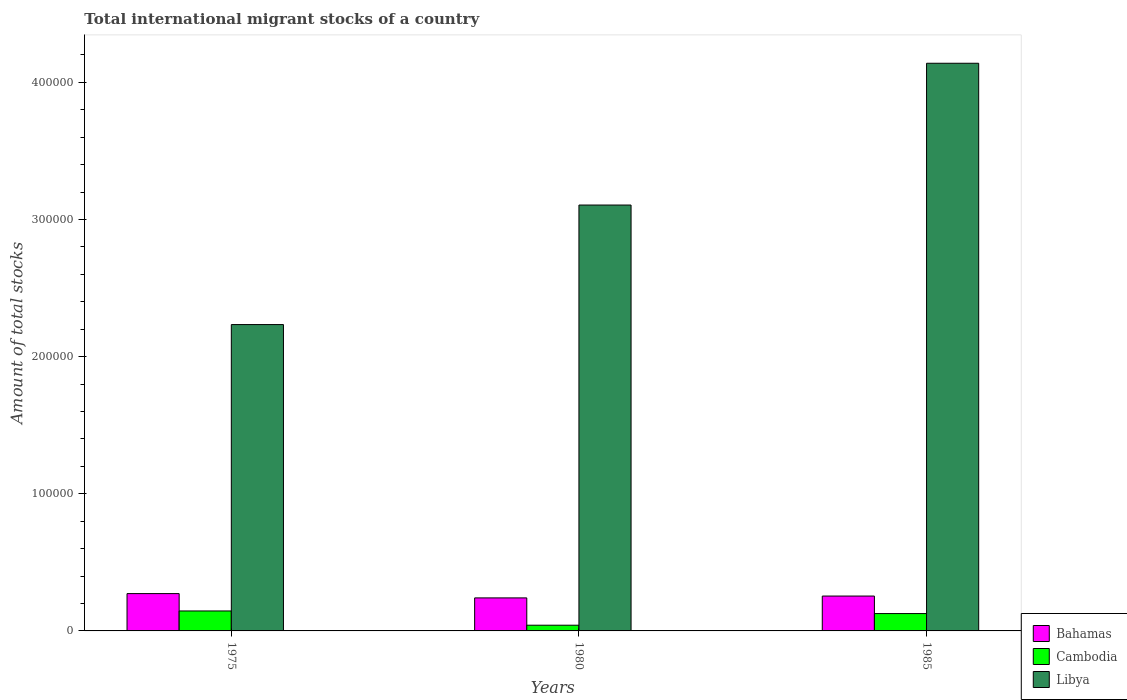How many different coloured bars are there?
Offer a very short reply. 3. How many groups of bars are there?
Your answer should be very brief. 3. Are the number of bars per tick equal to the number of legend labels?
Provide a succinct answer. Yes. How many bars are there on the 2nd tick from the left?
Your answer should be very brief. 3. What is the label of the 1st group of bars from the left?
Provide a succinct answer. 1975. In how many cases, is the number of bars for a given year not equal to the number of legend labels?
Offer a terse response. 0. What is the amount of total stocks in in Libya in 1975?
Provide a succinct answer. 2.23e+05. Across all years, what is the maximum amount of total stocks in in Libya?
Offer a very short reply. 4.14e+05. Across all years, what is the minimum amount of total stocks in in Libya?
Offer a terse response. 2.23e+05. In which year was the amount of total stocks in in Libya maximum?
Offer a terse response. 1985. In which year was the amount of total stocks in in Libya minimum?
Your answer should be very brief. 1975. What is the total amount of total stocks in in Libya in the graph?
Provide a succinct answer. 9.48e+05. What is the difference between the amount of total stocks in in Cambodia in 1975 and that in 1985?
Give a very brief answer. 1904. What is the difference between the amount of total stocks in in Bahamas in 1985 and the amount of total stocks in in Cambodia in 1980?
Provide a succinct answer. 2.13e+04. What is the average amount of total stocks in in Cambodia per year?
Give a very brief answer. 1.05e+04. In the year 1985, what is the difference between the amount of total stocks in in Bahamas and amount of total stocks in in Cambodia?
Give a very brief answer. 1.28e+04. What is the ratio of the amount of total stocks in in Cambodia in 1980 to that in 1985?
Ensure brevity in your answer.  0.33. What is the difference between the highest and the second highest amount of total stocks in in Libya?
Keep it short and to the point. 1.03e+05. What is the difference between the highest and the lowest amount of total stocks in in Bahamas?
Offer a very short reply. 3139. What does the 3rd bar from the left in 1980 represents?
Offer a very short reply. Libya. What does the 2nd bar from the right in 1975 represents?
Your response must be concise. Cambodia. Is it the case that in every year, the sum of the amount of total stocks in in Cambodia and amount of total stocks in in Bahamas is greater than the amount of total stocks in in Libya?
Your answer should be compact. No. Are all the bars in the graph horizontal?
Make the answer very short. No. What is the difference between two consecutive major ticks on the Y-axis?
Your answer should be very brief. 1.00e+05. Where does the legend appear in the graph?
Your answer should be very brief. Bottom right. What is the title of the graph?
Make the answer very short. Total international migrant stocks of a country. What is the label or title of the X-axis?
Provide a short and direct response. Years. What is the label or title of the Y-axis?
Offer a terse response. Amount of total stocks. What is the Amount of total stocks in Bahamas in 1975?
Your answer should be compact. 2.72e+04. What is the Amount of total stocks in Cambodia in 1975?
Your answer should be very brief. 1.46e+04. What is the Amount of total stocks in Libya in 1975?
Ensure brevity in your answer.  2.23e+05. What is the Amount of total stocks in Bahamas in 1980?
Offer a terse response. 2.41e+04. What is the Amount of total stocks of Cambodia in 1980?
Offer a very short reply. 4168. What is the Amount of total stocks in Libya in 1980?
Your response must be concise. 3.11e+05. What is the Amount of total stocks of Bahamas in 1985?
Your answer should be compact. 2.54e+04. What is the Amount of total stocks of Cambodia in 1985?
Offer a terse response. 1.26e+04. What is the Amount of total stocks of Libya in 1985?
Make the answer very short. 4.14e+05. Across all years, what is the maximum Amount of total stocks in Bahamas?
Provide a succinct answer. 2.72e+04. Across all years, what is the maximum Amount of total stocks in Cambodia?
Offer a terse response. 1.46e+04. Across all years, what is the maximum Amount of total stocks in Libya?
Provide a short and direct response. 4.14e+05. Across all years, what is the minimum Amount of total stocks of Bahamas?
Keep it short and to the point. 2.41e+04. Across all years, what is the minimum Amount of total stocks of Cambodia?
Provide a succinct answer. 4168. Across all years, what is the minimum Amount of total stocks in Libya?
Your answer should be compact. 2.23e+05. What is the total Amount of total stocks of Bahamas in the graph?
Offer a terse response. 7.67e+04. What is the total Amount of total stocks of Cambodia in the graph?
Give a very brief answer. 3.14e+04. What is the total Amount of total stocks in Libya in the graph?
Provide a short and direct response. 9.48e+05. What is the difference between the Amount of total stocks of Bahamas in 1975 and that in 1980?
Your response must be concise. 3139. What is the difference between the Amount of total stocks of Cambodia in 1975 and that in 1980?
Provide a succinct answer. 1.04e+04. What is the difference between the Amount of total stocks of Libya in 1975 and that in 1980?
Provide a short and direct response. -8.72e+04. What is the difference between the Amount of total stocks in Bahamas in 1975 and that in 1985?
Your response must be concise. 1788. What is the difference between the Amount of total stocks of Cambodia in 1975 and that in 1985?
Keep it short and to the point. 1904. What is the difference between the Amount of total stocks in Libya in 1975 and that in 1985?
Ensure brevity in your answer.  -1.91e+05. What is the difference between the Amount of total stocks in Bahamas in 1980 and that in 1985?
Your answer should be very brief. -1351. What is the difference between the Amount of total stocks in Cambodia in 1980 and that in 1985?
Provide a succinct answer. -8479. What is the difference between the Amount of total stocks in Libya in 1980 and that in 1985?
Your answer should be very brief. -1.03e+05. What is the difference between the Amount of total stocks of Bahamas in 1975 and the Amount of total stocks of Cambodia in 1980?
Keep it short and to the point. 2.30e+04. What is the difference between the Amount of total stocks in Bahamas in 1975 and the Amount of total stocks in Libya in 1980?
Offer a very short reply. -2.83e+05. What is the difference between the Amount of total stocks of Cambodia in 1975 and the Amount of total stocks of Libya in 1980?
Offer a very short reply. -2.96e+05. What is the difference between the Amount of total stocks in Bahamas in 1975 and the Amount of total stocks in Cambodia in 1985?
Offer a terse response. 1.46e+04. What is the difference between the Amount of total stocks of Bahamas in 1975 and the Amount of total stocks of Libya in 1985?
Your response must be concise. -3.87e+05. What is the difference between the Amount of total stocks in Cambodia in 1975 and the Amount of total stocks in Libya in 1985?
Make the answer very short. -3.99e+05. What is the difference between the Amount of total stocks of Bahamas in 1980 and the Amount of total stocks of Cambodia in 1985?
Your response must be concise. 1.14e+04. What is the difference between the Amount of total stocks of Bahamas in 1980 and the Amount of total stocks of Libya in 1985?
Your response must be concise. -3.90e+05. What is the difference between the Amount of total stocks of Cambodia in 1980 and the Amount of total stocks of Libya in 1985?
Keep it short and to the point. -4.10e+05. What is the average Amount of total stocks of Bahamas per year?
Your response must be concise. 2.56e+04. What is the average Amount of total stocks in Cambodia per year?
Offer a very short reply. 1.05e+04. What is the average Amount of total stocks in Libya per year?
Provide a short and direct response. 3.16e+05. In the year 1975, what is the difference between the Amount of total stocks in Bahamas and Amount of total stocks in Cambodia?
Make the answer very short. 1.27e+04. In the year 1975, what is the difference between the Amount of total stocks in Bahamas and Amount of total stocks in Libya?
Your response must be concise. -1.96e+05. In the year 1975, what is the difference between the Amount of total stocks in Cambodia and Amount of total stocks in Libya?
Keep it short and to the point. -2.09e+05. In the year 1980, what is the difference between the Amount of total stocks of Bahamas and Amount of total stocks of Cambodia?
Your answer should be compact. 1.99e+04. In the year 1980, what is the difference between the Amount of total stocks of Bahamas and Amount of total stocks of Libya?
Your answer should be very brief. -2.86e+05. In the year 1980, what is the difference between the Amount of total stocks of Cambodia and Amount of total stocks of Libya?
Your answer should be compact. -3.06e+05. In the year 1985, what is the difference between the Amount of total stocks in Bahamas and Amount of total stocks in Cambodia?
Ensure brevity in your answer.  1.28e+04. In the year 1985, what is the difference between the Amount of total stocks in Bahamas and Amount of total stocks in Libya?
Give a very brief answer. -3.89e+05. In the year 1985, what is the difference between the Amount of total stocks in Cambodia and Amount of total stocks in Libya?
Your response must be concise. -4.01e+05. What is the ratio of the Amount of total stocks of Bahamas in 1975 to that in 1980?
Keep it short and to the point. 1.13. What is the ratio of the Amount of total stocks in Cambodia in 1975 to that in 1980?
Make the answer very short. 3.49. What is the ratio of the Amount of total stocks in Libya in 1975 to that in 1980?
Provide a succinct answer. 0.72. What is the ratio of the Amount of total stocks of Bahamas in 1975 to that in 1985?
Provide a short and direct response. 1.07. What is the ratio of the Amount of total stocks in Cambodia in 1975 to that in 1985?
Keep it short and to the point. 1.15. What is the ratio of the Amount of total stocks in Libya in 1975 to that in 1985?
Your answer should be very brief. 0.54. What is the ratio of the Amount of total stocks of Bahamas in 1980 to that in 1985?
Make the answer very short. 0.95. What is the ratio of the Amount of total stocks of Cambodia in 1980 to that in 1985?
Make the answer very short. 0.33. What is the ratio of the Amount of total stocks of Libya in 1980 to that in 1985?
Make the answer very short. 0.75. What is the difference between the highest and the second highest Amount of total stocks in Bahamas?
Provide a short and direct response. 1788. What is the difference between the highest and the second highest Amount of total stocks in Cambodia?
Give a very brief answer. 1904. What is the difference between the highest and the second highest Amount of total stocks in Libya?
Provide a short and direct response. 1.03e+05. What is the difference between the highest and the lowest Amount of total stocks in Bahamas?
Your response must be concise. 3139. What is the difference between the highest and the lowest Amount of total stocks in Cambodia?
Offer a very short reply. 1.04e+04. What is the difference between the highest and the lowest Amount of total stocks of Libya?
Provide a succinct answer. 1.91e+05. 